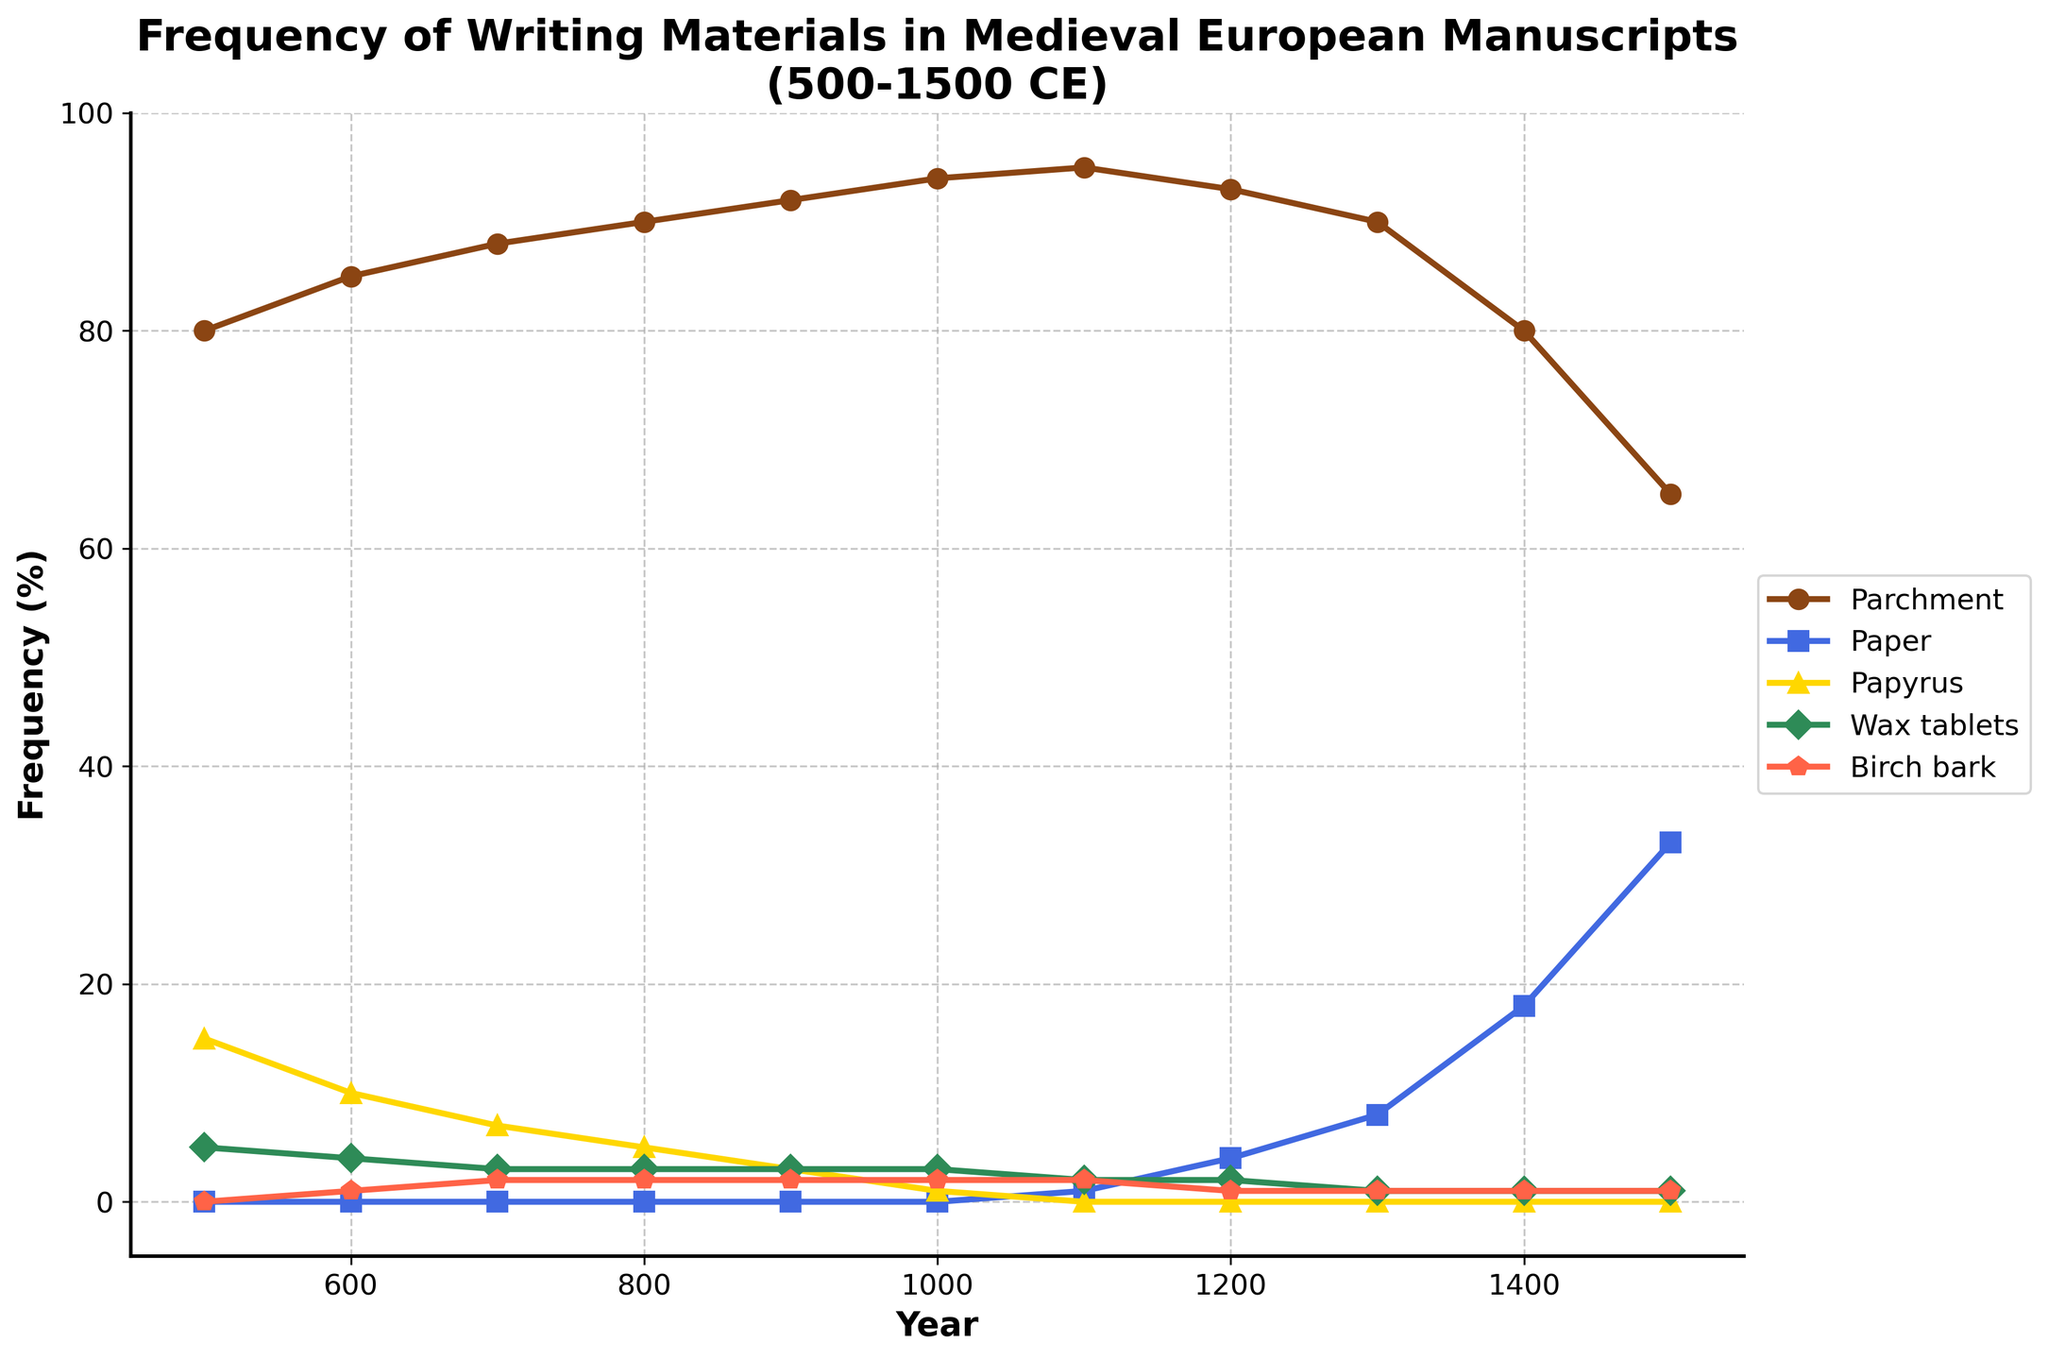What's the general trend of the frequency of parchment usage from 500 to 1500 CE? The frequency of parchment usage starts at 80% in 500 CE and gradually increases over the centuries. It peaks in 1100 CE at 95%, then slowly declines, reaching 65% by 1500 CE.
Answer: Increase initially, then decrease Which material saw the largest increase in usage from 1100 to 1500 CE? From 1100 to 1500 CE, paper usage increased from 1% to 33%. Other materials did not experience such a significant rise during this period.
Answer: Paper By how much did the frequency of papyrus decrease from 500 to 1000 CE? The frequency of papyrus usage decreased from 15% in 500 CE to 1% in 1000 CE. Subtracting these values gives us a decrease of 14%.
Answer: 14% How does the frequency of wax tablets in 700 CE compare to that in 1500 CE? The frequency of wax tablets is 3% in 700 CE and remains constant at 1% from 1100 CE to 1500 CE. The frequency is higher in 700 CE.
Answer: Higher in 700 CE What is the combined frequency of parchment and paper in 1400 CE? The frequencies of parchment and paper in 1400 CE are 80% and 18%, respectively. Adding these together gives 80 + 18 = 98%.
Answer: 98% What happens to the usage of birch bark from 900 CE to 1500 CE? The usage of birch bark remains constant at 2% from 900 CE to 1000 CE, then drops to 1% from 1200 CE to 1500 CE.
Answer: Remains constant then drops Which writing material had the highest frequency in 600 CE, and what was the value? In 600 CE, parchment had the highest frequency at 85%.
Answer: Parchment, 85% Between which centuries did paper usage surpass 10% for the first time? Paper usage surpasses 10% between 1200 CE (4%) and 1300 CE (8%), and 1400 CE (18%). Thus, it surpasses 10% between 1300 CE and 1400 CE.
Answer: 1300-1400 CE What is the difference in frequency of parchment and wax tablets in 900 CE? The frequency of parchment in 900 CE is 92%, while that of wax tablets is 3%. The difference is 92 - 3 = 89%.
Answer: 89% 